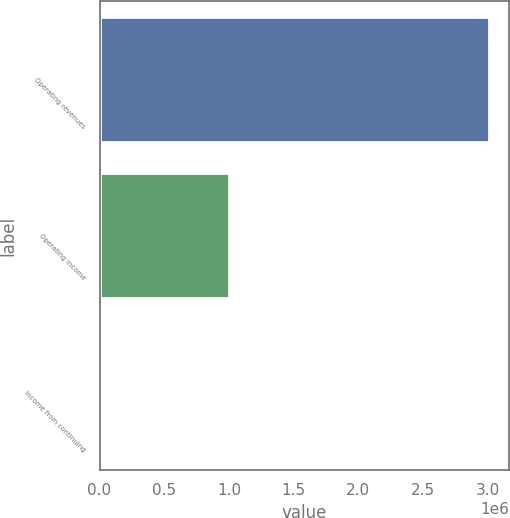Convert chart to OTSL. <chart><loc_0><loc_0><loc_500><loc_500><bar_chart><fcel>Operating revenues<fcel>Operating income<fcel>Income from continuing<nl><fcel>3.01133e+06<fcel>1.00258e+06<fcel>2.39<nl></chart> 